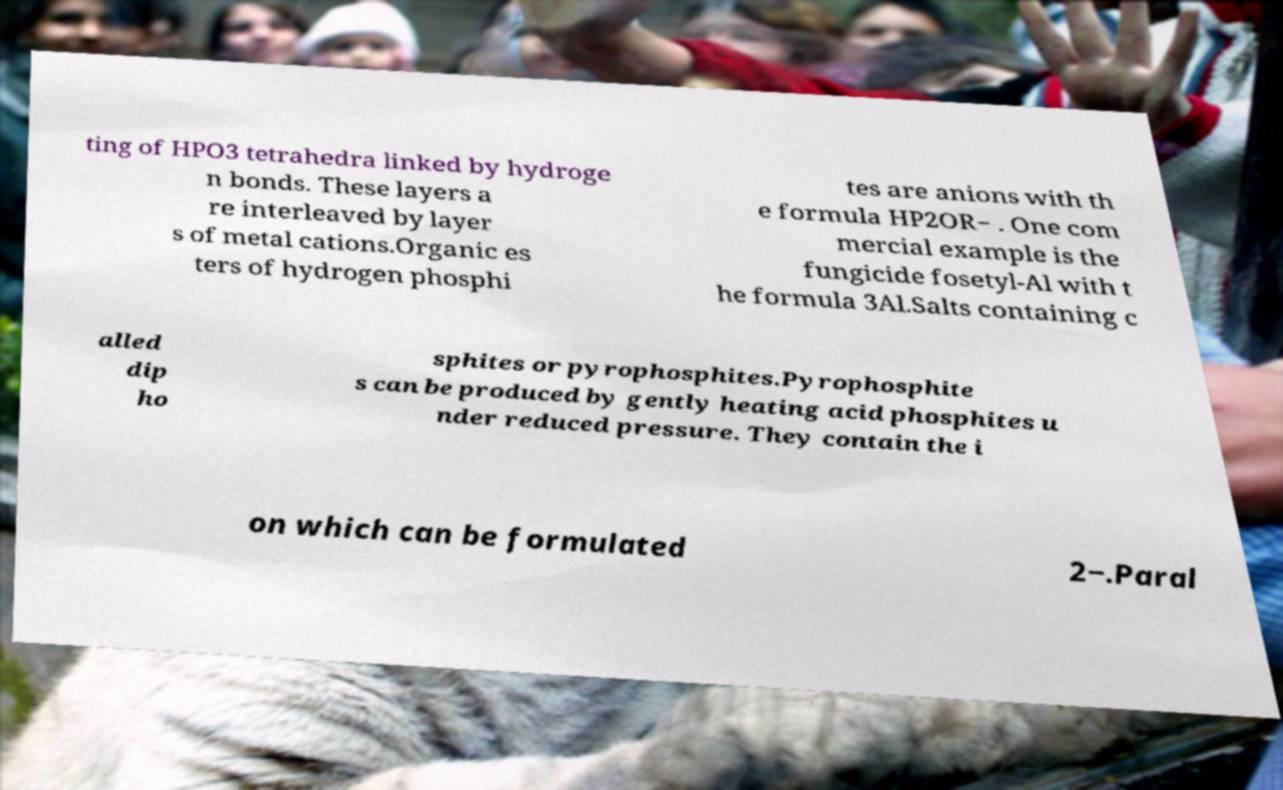Can you accurately transcribe the text from the provided image for me? ting of HPO3 tetrahedra linked by hydroge n bonds. These layers a re interleaved by layer s of metal cations.Organic es ters of hydrogen phosphi tes are anions with th e formula HP2OR− . One com mercial example is the fungicide fosetyl-Al with t he formula 3Al.Salts containing c alled dip ho sphites or pyrophosphites.Pyrophosphite s can be produced by gently heating acid phosphites u nder reduced pressure. They contain the i on which can be formulated 2−.Paral 